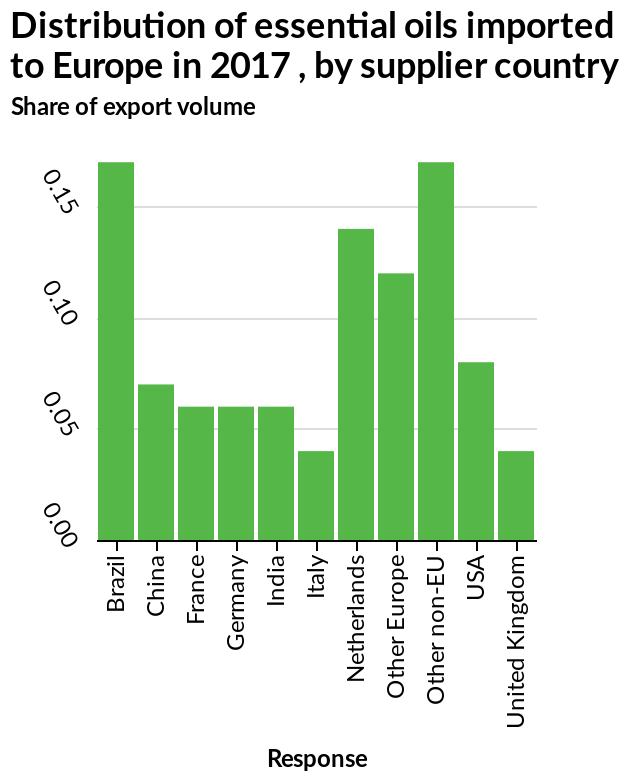<image>
What does the x-axis represent in this bar graph? The x-axis represents the supplier countries of the essential oils, starting from Brazil and ending at the United Kingdom. 